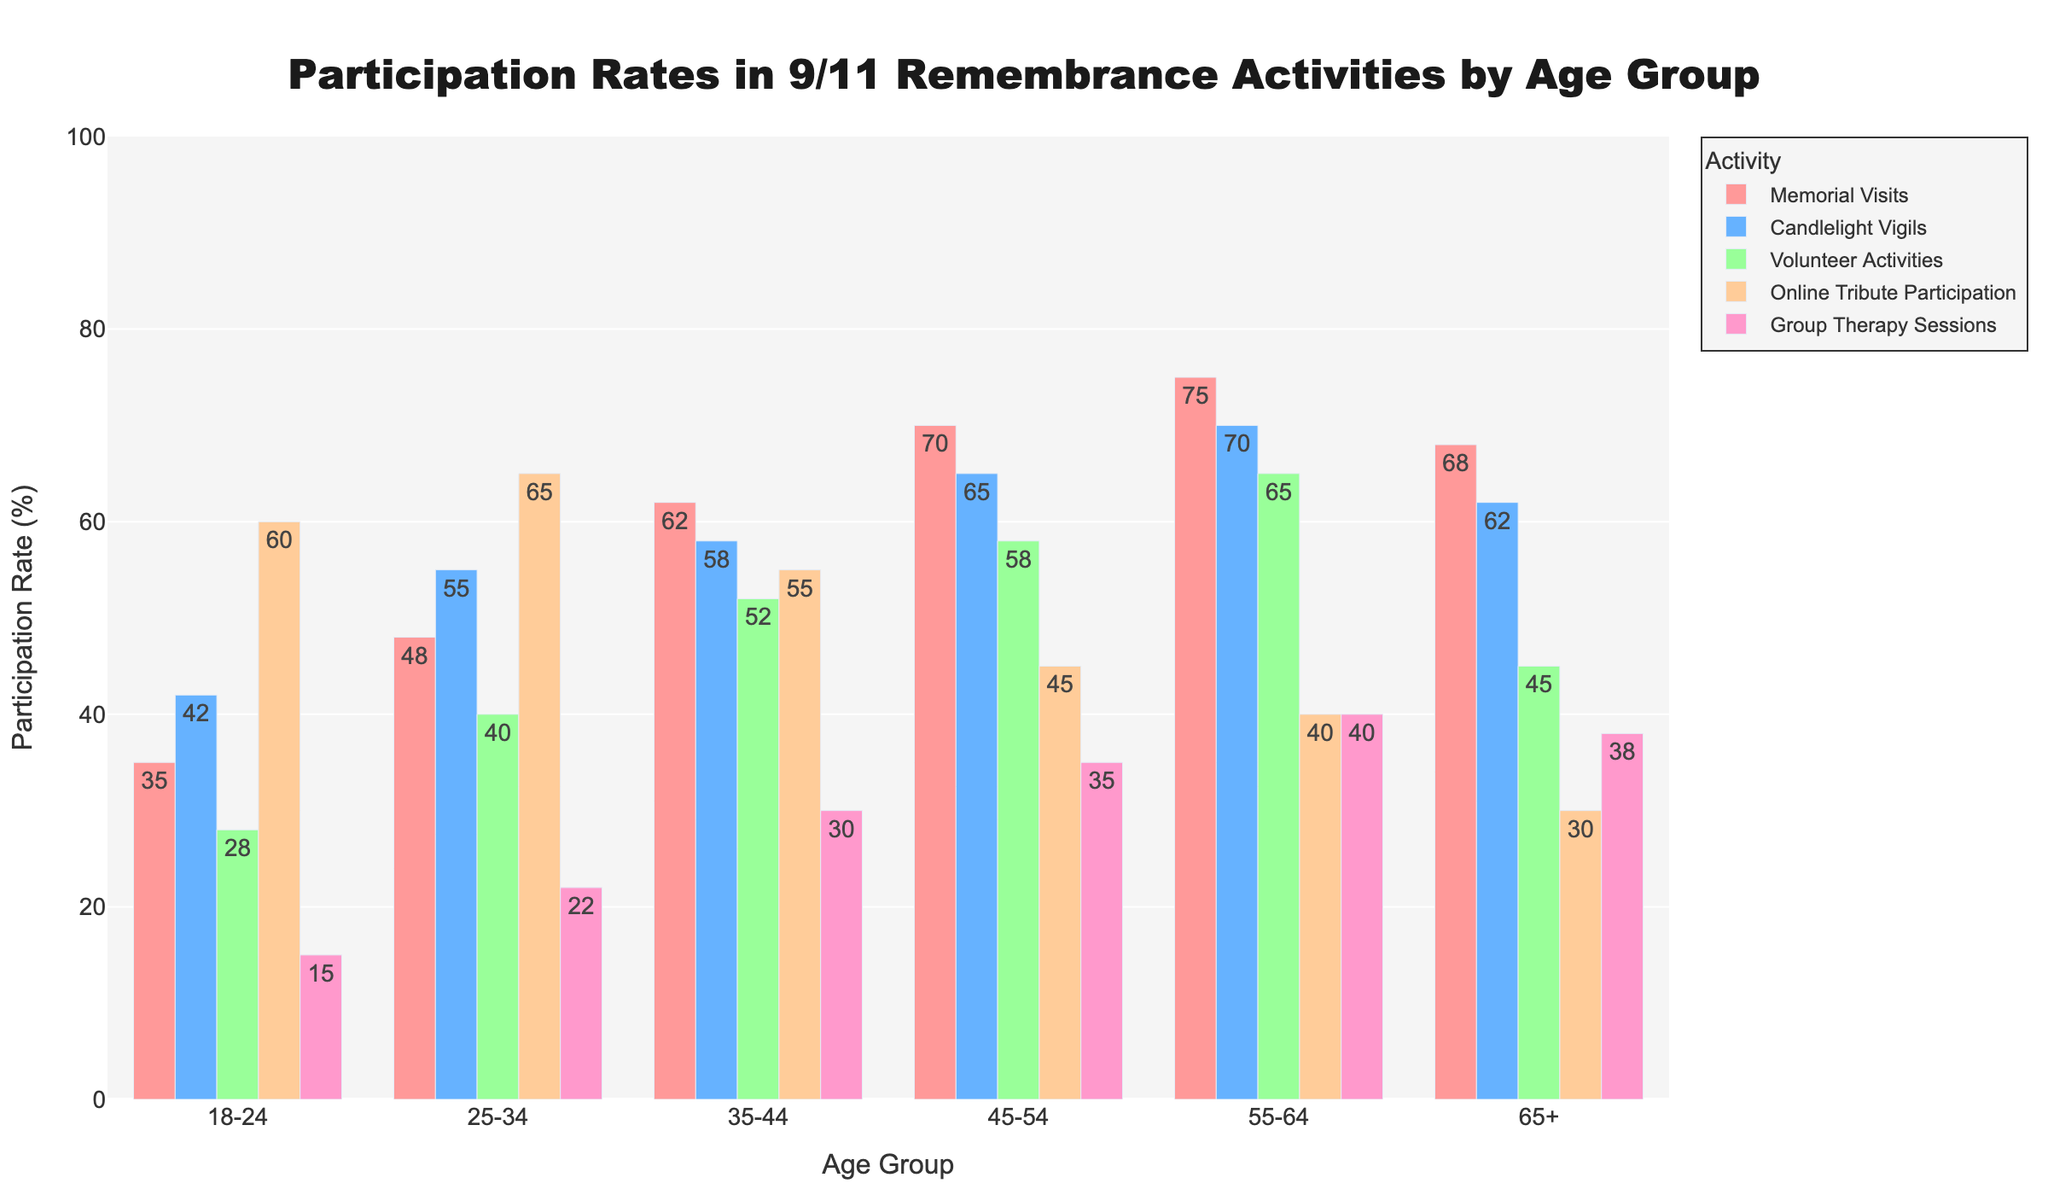What's the most popular remembrance activity for the 18-24 age group? Look at the bars representing the 18-24 age group and identify the one with the highest height. This is the bar for 'Online Tribute Participation' with a value of 60.
Answer: Online Tribute Participation How does the participation rate in volunteer activities change across the age groups? Examine the bars for 'Volunteer Activities' across all age groups. The participation rates are 28, 40, 52, 58, 65, and 45. It increases from 18-24 to 55-64 and then decreases for the 65+ group.
Answer: Increases, then decreases Which age group has the highest participation rate in memorial visits? Find the tallest bar in the 'Memorial Visits' category. The highest bar belongs to the 55-64 age group with a participation rate of 75.
Answer: 55-64 What's the difference in participation rates for candlelight vigils between the 25-34 and 45-54 age groups? Look at the bars for 'Candlelight Vigils' for the 25-34 and 45-54 age groups. Their participation rates are 55 and 65 respectively. Calculate the difference: 65 - 55 = 10.
Answer: 10 Which activity has the least participation in the 65+ age group? Identify the shortest bar in the 65+ age group category. The shortest bar is for 'Online Tribute Participation' with a value of 30.
Answer: Online Tribute Participation What is the average participation rate across all activities for the 35-44 age group? Add the participation rates for all activities in the 35-44 age group: 62, 58, 52, 55, 30. The sum is 257. Divide by the number of activities (5): 257 / 5 = 51.4.
Answer: 51.4 What’s the difference in participation rates for group therapy sessions between the 55-64 and 18-24 age groups? Look at the bars for 'Group Therapy Sessions' in the 55-64 and 18-24 age groups. Their participation rates are 40 and 15 respectively. Calculate the difference: 40 - 15 = 25.
Answer: 25 Which activity shows a decreasing trend in participation as the age groups progress? Analyze each activity's bars across all age groups to identify a decreasing pattern. 'Online Tribute Participation' decreases consistently (60, 65, 55, 45, 40, 30).
Answer: Online Tribute Participation Which age group has the highest average participation rate across all activities? Calculate the average participation rate for each age group by summing their values for all activities and dividing by the number of activities (5). Compare the average rates:
18-24: (35+42+28+60+15)/5 = 36
25-34: (48+55+40+65+22)/5 = 46
35-44: (62+58+52+55+30)/5 = 51.4
45-54: (70+65+58+45+35)/5 = 54.6
55-64: (75+70+65+40+40)/5 = 58
65+: (68+62+45+30+38)/5 = 48.6
The 55-64 age group has the highest average participation rate.
Answer: 55-64 Which activity has the closest participation rate between the 18-24 and 25-34 age groups? Compare the bars for 'Memorial Visits', 'Candlelight Vigils', 'Volunteer Activities', 'Online Tribute Participation', and 'Group Therapy Sessions' between the 18-24 and 25-34 age groups. The smallest difference is in 'Online Tribute Participation' (60 and 65).
Answer: Online Tribute Participation 